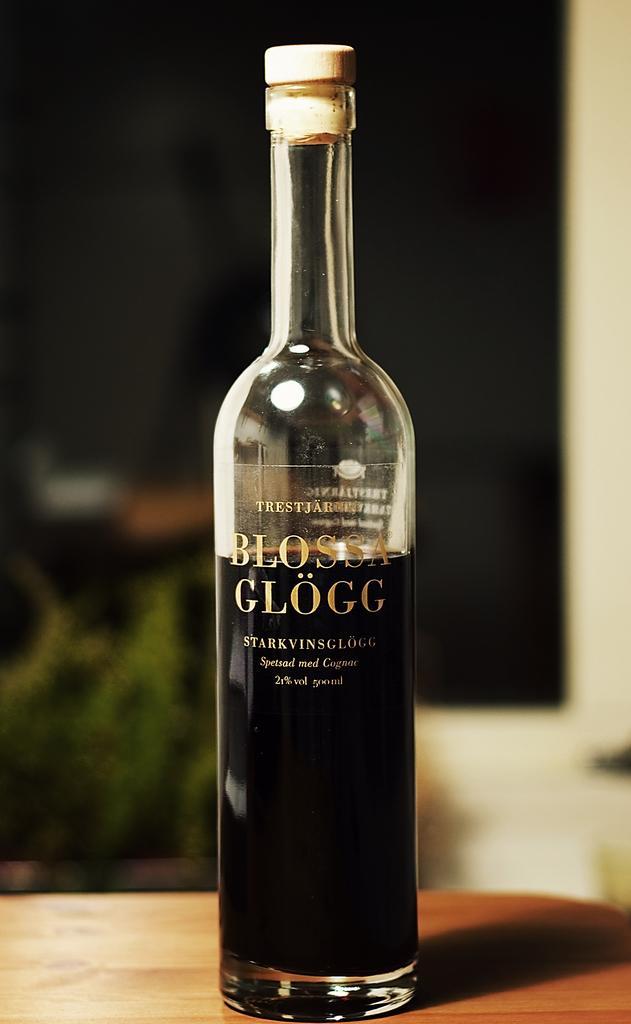How would you summarize this image in a sentence or two? This picture shows a wine bottle on the table 